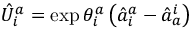<formula> <loc_0><loc_0><loc_500><loc_500>\hat { U } _ { i } ^ { a } = \exp { \theta _ { i } ^ { a } \left ( \hat { a } _ { i } ^ { a } - \hat { a } _ { a } ^ { i } \right ) }</formula> 